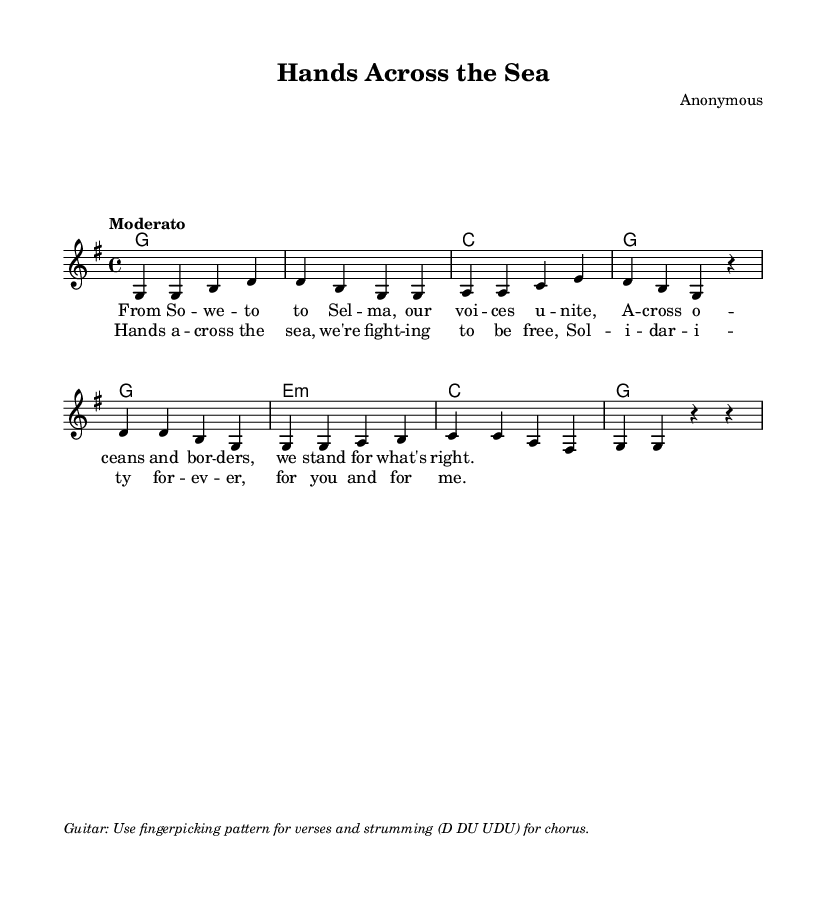What is the key signature of this music? The key signature is indicated at the beginning of the staff. It shows one sharp, which identifies the key as G major.
Answer: G major What is the time signature of this music? The time signature is located at the beginning of the score, showing a '4/4' symbol. This indicates that there are four beats per measure and a quarter note gets one beat.
Answer: 4/4 What is the tempo marking for this piece? The tempo marking appears in the score after the key and time signatures, and it indicates the speed of the piece as "Moderato."
Answer: Moderato How many measures are in the verse section? By counting the measures in the melody section labeled as verse, there are a total of four measures.
Answer: Four What kind of strumming pattern is indicated for the chorus? The strumming pattern is noted in the markup section indicating "D DU UDU" for the chorus, which stands for Down, Down-Up, Up-Down-Up.
Answer: D DU UDU Which musical section contains the lyrics "Hands a--cross the sea"? The lyrics "Hands a--cross the sea" are part of the chorus section, as marked accordingly in the lyrics.
Answer: Chorus What type of chord is used in the first measure of the verse? The first measure of the verse contains a G major chord, as presented in the harmonies section.
Answer: G major 